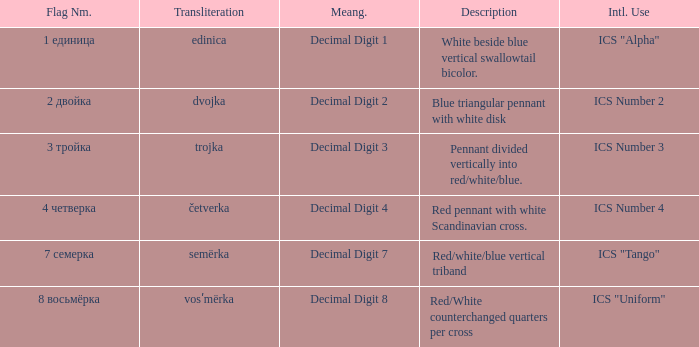What is the international use of the 1 единица flag? ICS "Alpha". 